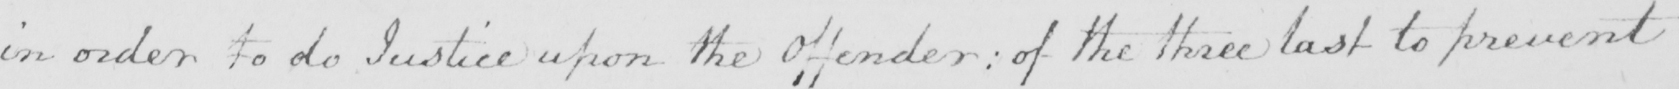Transcribe the text shown in this historical manuscript line. in order to do Justice upon the Offender :  of the three last to prevent 